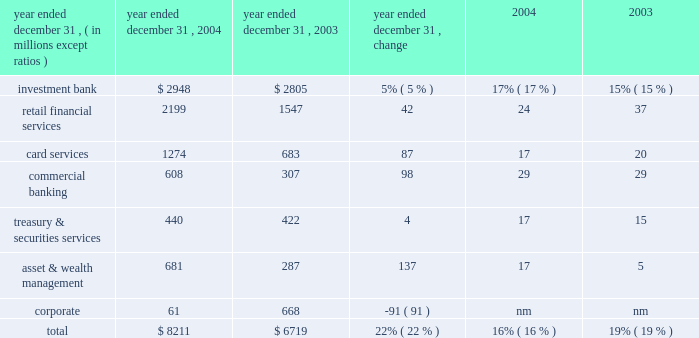Jpmorgan chase & co .
/ 2004 annual report 29 firms were aligned to provide consistency across the business segments .
In addition , expenses related to certain corporate functions , technology and operations ceased to be allocated to the business segments and are retained in corporate .
These retained expenses include parent company costs that would not be incurred if the segments were stand-alone businesses ; adjustments to align certain corporate staff , technology and operations allocations with market prices ; and other one-time items not aligned with the business segments .
Capital allocation each business segment is allocated capital by taking into consideration stand- alone peer comparisons , economic risk measures and regulatory capital requirements .
The amount of capital assigned to each business is referred to as equity .
Effective with the third quarter of 2004 , new methodologies were implemented to calculate the amount of capital allocated to each segment .
As part of the new methodology , goodwill , as well as the associated capital , is allocated solely to corporate .
Although u.s .
Gaap requires the allocation of goodwill to the business segments for impairment testing ( see note 15 on page 109 of this annual report ) , the firm has elected not to include goodwill or the related capital in each of the business segments for management reporting purposes .
See the capital management section on page 50 of this annual report for a discussion of the equity framework .
Credit reimbursement tss reimburses the ib for credit portfolio exposures the ib manages on behalf of clients the segments share .
At the time of the merger , the reimbursement methodology was revised to be based on pre-tax earnings , net of the cost of capital related to those exposures .
Prior to the merger , the credit reimburse- ment was based on pre-tax earnings , plus the allocated capital associated with the shared clients .
Tax-equivalent adjustments segment results reflect revenues on a tax-equivalent basis for segment reporting purposes .
Refer to page 25 of this annual report for additional details .
Description of business segment reporting methodology results of the business segments are intended to reflect each segment as if it were essentially a stand-alone business .
The management reporting process that derives these results allocates income and expense using market-based methodologies .
At the time of the merger , several of the allocation method- ologies were revised , as noted below .
The changes became effective july 1 , 2004 .
As prior periods have not been revised to reflect these new methodologies , they are not comparable to the presentation of periods begin- ning with the third quarter of 2004 .
Further , the firm intends to continue to assess the assumptions , methodologies and reporting reclassifications used for segment reporting , and it is anticipated that further refinements may be implemented in future periods .
Revenue sharing when business segments join efforts to sell products and services to the firm 2019s clients , the participating business segments agree to share revenues from those transactions .
These revenue sharing agreements were revised on the merger date to provide consistency across the lines of businesses .
Funds transfer pricing funds transfer pricing ( 201cftp 201d ) is used to allocate interest income and interest expense to each line of business and also serves to transfer interest rate risk to corporate .
While business segments may periodically retain interest rate exposures related to customer pricing or other business-specific risks , the bal- ance of the firm 2019s overall interest rate risk exposure is included and managed in corporate .
In the third quarter of 2004 , ftp was revised to conform the policies of the combined firms .
Expense allocation where business segments use services provided by support units within the firm , the costs of those support units are allocated to the business segments .
Those expenses are allocated based on their actual cost , or the lower of actual cost or market cost , as well as upon usage of the services provided .
Effective with the third quarter of 2004 , the cost allocation methodologies of the heritage segment results 2013 operating basis ( a ) ( b ) ( table continued from previous page ) year ended december 31 , operating earnings return on common equity 2013 goodwill ( c ) .

In 2004 what was the ratio of the investment bank to the retail financial services operations operating earnings? 
Computations: (2948 / 2199)
Answer: 1.34061. 